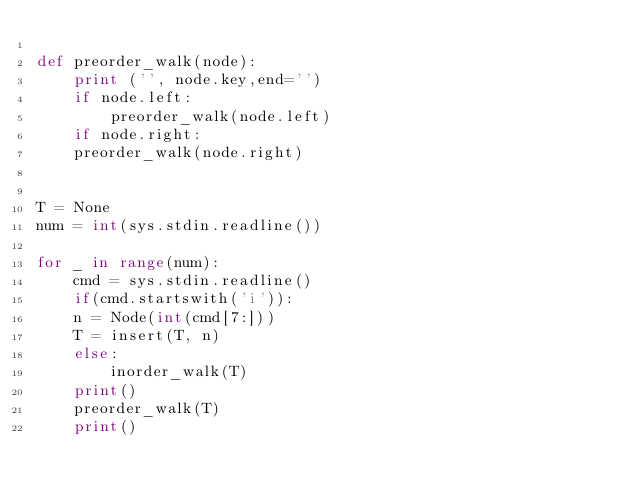Convert code to text. <code><loc_0><loc_0><loc_500><loc_500><_Python_>
def preorder_walk(node):
    print ('', node.key,end='')
    if node.left:
        preorder_walk(node.left)
    if node.right:
	preorder_walk(node.right)


T = None
num = int(sys.stdin.readline())

for _ in range(num):
    cmd = sys.stdin.readline()
    if(cmd.startswith('i')):
	n = Node(int(cmd[7:]))
	T = insert(T, n)
    else:
        inorder_walk(T)
	print()
	preorder_walk(T)
	print()</code> 